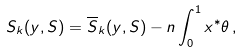Convert formula to latex. <formula><loc_0><loc_0><loc_500><loc_500>S _ { k } ( y , S ) = \overline { S } _ { k } ( y , S ) - n \int _ { 0 } ^ { 1 } x ^ { * } \theta \, ,</formula> 